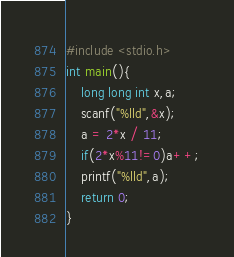<code> <loc_0><loc_0><loc_500><loc_500><_C_>#include <stdio.h>
int main(){
	long long int x,a;
	scanf("%lld",&x);
	a = 2*x / 11;
	if(2*x%11!=0)a++;
	printf("%lld",a);	
	return 0;
}</code> 